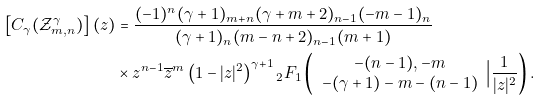<formula> <loc_0><loc_0><loc_500><loc_500>\left [ C _ { \gamma } ( \mathcal { Z } _ { m , n } ^ { \gamma } ) \right ] ( z ) & = \frac { ( - 1 ) ^ { n } ( \gamma + 1 ) _ { m + n } ( \gamma + m + 2 ) _ { n - 1 } ( - m - 1 ) _ { n } } { ( \gamma + 1 ) _ { n } ( m - n + 2 ) _ { n - 1 } ( m + 1 ) } \\ & \times z ^ { n - 1 } \overline { z } ^ { m } \left ( 1 - | z | ^ { 2 } \right ) ^ { \gamma + 1 } { _ { 2 } F _ { 1 } } \left ( \begin{array} { c } - ( n - 1 ) , - m \\ - ( \gamma + 1 ) - m - ( n - 1 ) \end{array} \Big | \frac { 1 } { | z | ^ { 2 } } \right ) .</formula> 